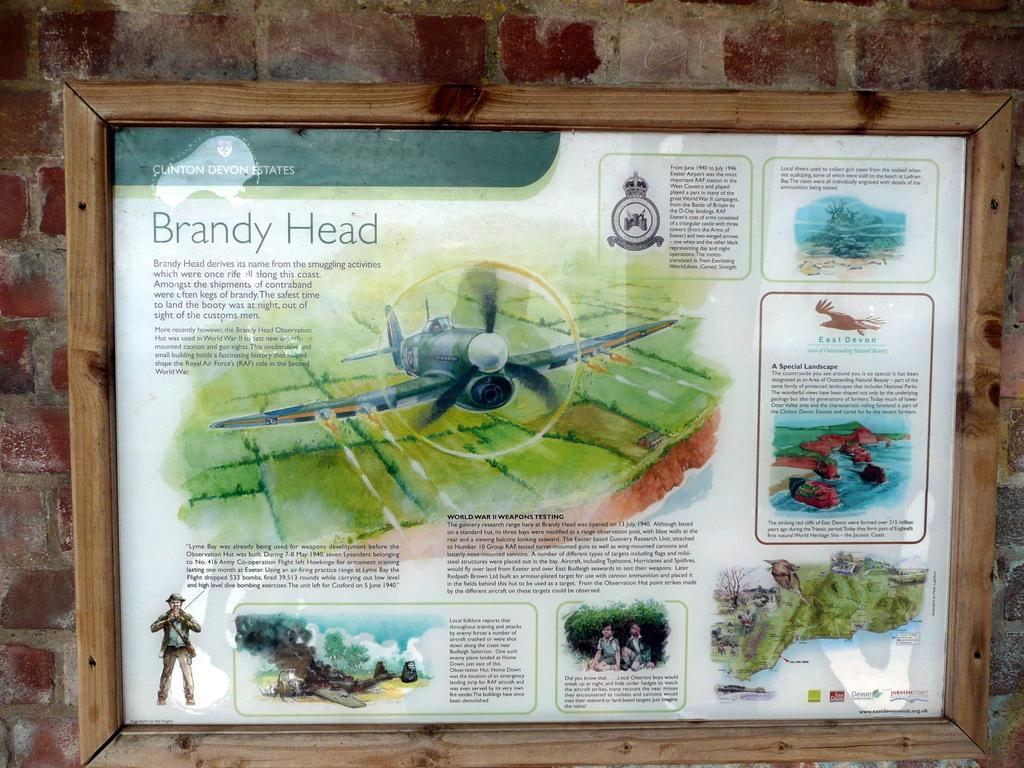What is the main subject in the center of the image? There is a frame in the center of the image on a wall. What is depicted within the frame? The frame contains an aircraft and other images. Where is the bell located in the image? There is no bell present in the image. How many bikes are visible in the image? There are no bikes visible in the image. 